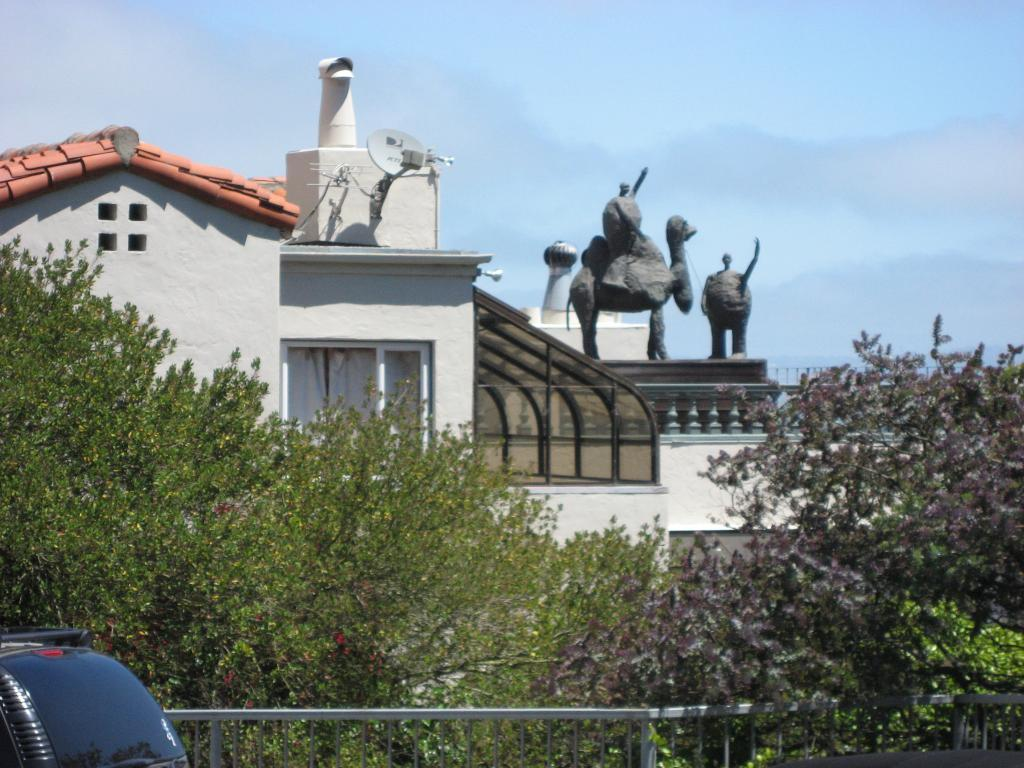What type of natural elements can be seen in the image? There are trees in the image. What architectural features are present in the image? There are walls, windows, curtains, railings, pillars, and an antenna in the image. What man-made objects can be seen in the image? There are glass objects, a box, statues, and a vehicle in the image. What can be seen in the background of the image? The sky is visible in the background of the image. How many jellyfish are swimming in the box in the image? There are no jellyfish present in the image, and the box does not contain any water for them to swim in. What type of boundary can be seen separating the trees and the walls in the image? There is no specific boundary separating the trees and the walls in the image; they are simply located next to each other. 